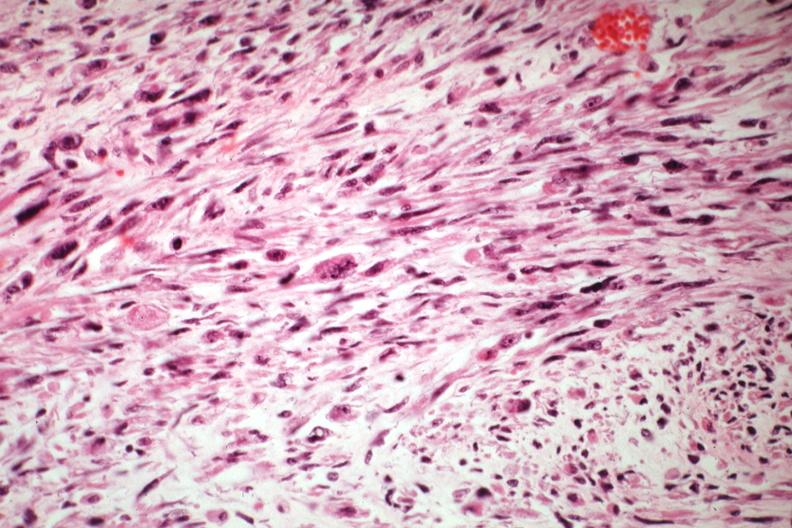s yellow color present?
Answer the question using a single word or phrase. No 